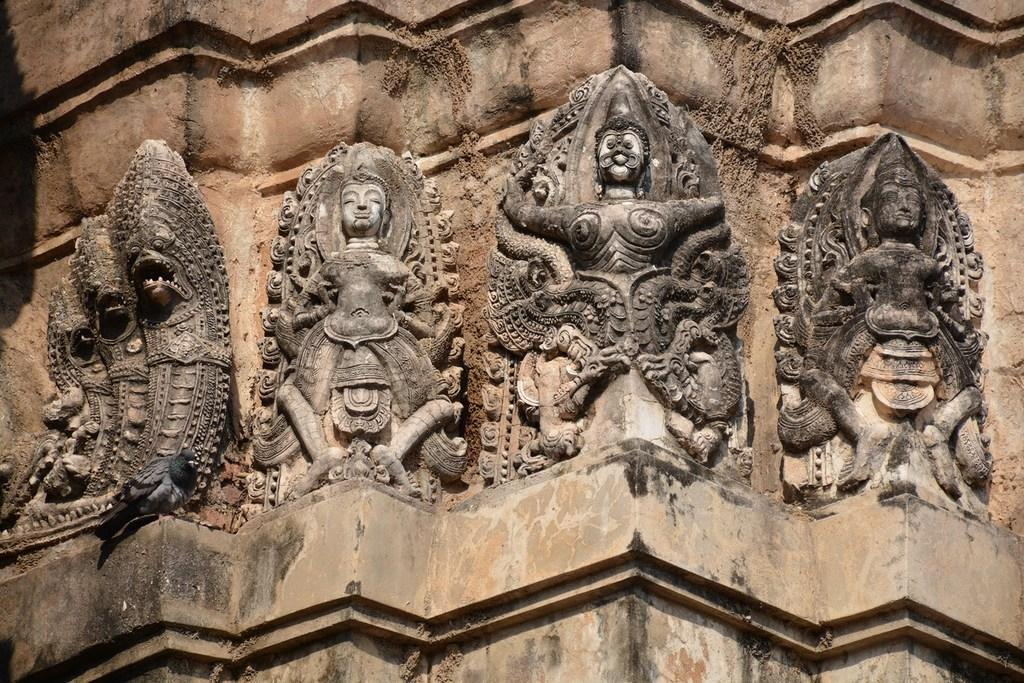How many sculptures are present in the image? There are four different sculptures in the image. Where are the sculptures located? The sculptures are on the wall. What type of clover can be seen growing near the sculptures in the image? There is no clover present in the image; it only features four sculptures on the wall. 